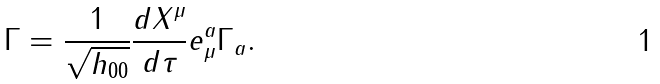Convert formula to latex. <formula><loc_0><loc_0><loc_500><loc_500>\Gamma = \frac { 1 } { \sqrt { h _ { 0 0 } } } \frac { d X ^ { \mu } } { d \tau } e ^ { a } _ { \mu } \Gamma _ { a } .</formula> 